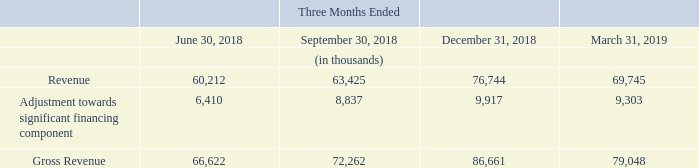Our revenues and operating results are significantly affected by the timing, number and breadth of our theatrical releases and their budgets, the timing of television syndication agreements, and our amortization policy for the first 12 months of commercial exploitation for a film. The timing of releases is determined based on several factors. A significant portion of the films we distribute are delivered to Indian theaters at times when theater attendance has traditionally been highest, including school holidays, national holidays and the festivals. This timing of releases also takes into account competitor film release dates, major cricket events in India and film production schedules. Significant holidays and festivals, such as Diwali, Eid and Christmas, occur during July to December each year, and the Indian Premier League cricket season generally occurs during April and May of each year. The Tamil New Year, called Pongal, falls in January each year making the quarter ending March an important one for Tamil releases.
Our quarterly results can vary from one period to the next, and the results of one quarter are not necessarily indicative of results for the next or any future quarter. Our revenue and operating results are therefore seasonal in nature due to the impact on income of the timing of new releases as well as timing and quantum of catalogue revenues.
What is taken into account while releasing films? School holidays, national holidays, the festivals, competitor film release dates, major cricket events in india, film production schedules. What was the revenue in three months ended June 2018?
Answer scale should be: thousand. 60,212. What is the adjustment towards significant financing component in three months ended June 2018?
Answer scale should be: thousand. 6,410. What are the Three months ended periods that have gross revenue exceeding $70,000 thousand? For row 7 find the cells which have values >70,000 and find the corresponding three months ended period
Answer: september 30, 2018, december 31, 2018, march 31, 2019. What is the average quarterly Adjustment towards significant financing component for  Three Months Ended June 30 2018 to march 31, 2019?
Answer scale should be: thousand. (6,410 + 8,837 + 9,917 + 9,303) / 4
Answer: 8616.75. What is the percentage increase / (decrease) in the Gross Revenue from Three Months Ended  December 2018 to March 2019?
Answer scale should be: percent. 79,048 / 86,661 - 1
Answer: -8.78. 